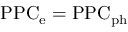Convert formula to latex. <formula><loc_0><loc_0><loc_500><loc_500>P P C _ { \mathrm { e } } = \mathrm { P P C _ { \mathrm { p h } } }</formula> 